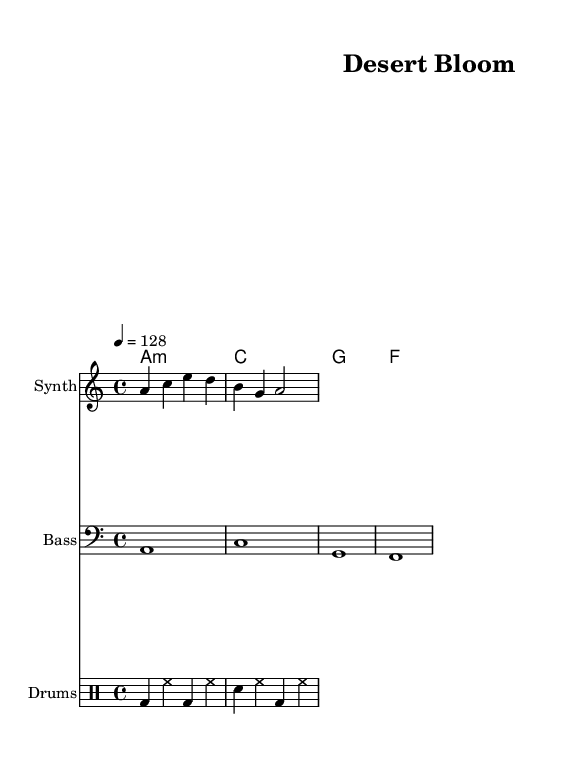What is the key signature of this music? The key signature is indicated at the beginning of the score after the \key command. In this case, it is set as A minor, which has no sharps or flats.
Answer: A minor What is the time signature of this piece? The time signature is shown at the beginning of the score following the \time command. Here, it is 4/4, meaning there are four beats per measure and the quarter note gets one beat.
Answer: 4/4 What is the tempo marking for the music? The tempo is given at the beginning of the score by the \tempo command, which states that the piece should be played at a speed of 128 beats per minute.
Answer: 128 How many measures are in the melody? By counting the individual segments in the melody section, we see there are a total of 2 measures indicated by the two groups of notes separated by vertical bars.
Answer: 2 What is the instrument designated for the melody part? The instrument name is specified in the score sections. Here, it states that the melody is played by a Synth, which is typical for electronic music.
Answer: Synth What type of chord progression is used in the harmonies? The chord progression follows a structure that can be deduced from the chords provided in the \chordmode section. It shows a sequence of four chords consisting of A minor, C major, G major, and F major, which is a common progression in electronic music.
Answer: A minor, C major, G major, F major What role do the drums play in this piece? The drums are indicated in a separate part labeled \drummode, showing a combination of bass drum and snare rhythms that provide the rhythmic foundation, essential for electronic tracks.
Answer: Rhythmic foundation 